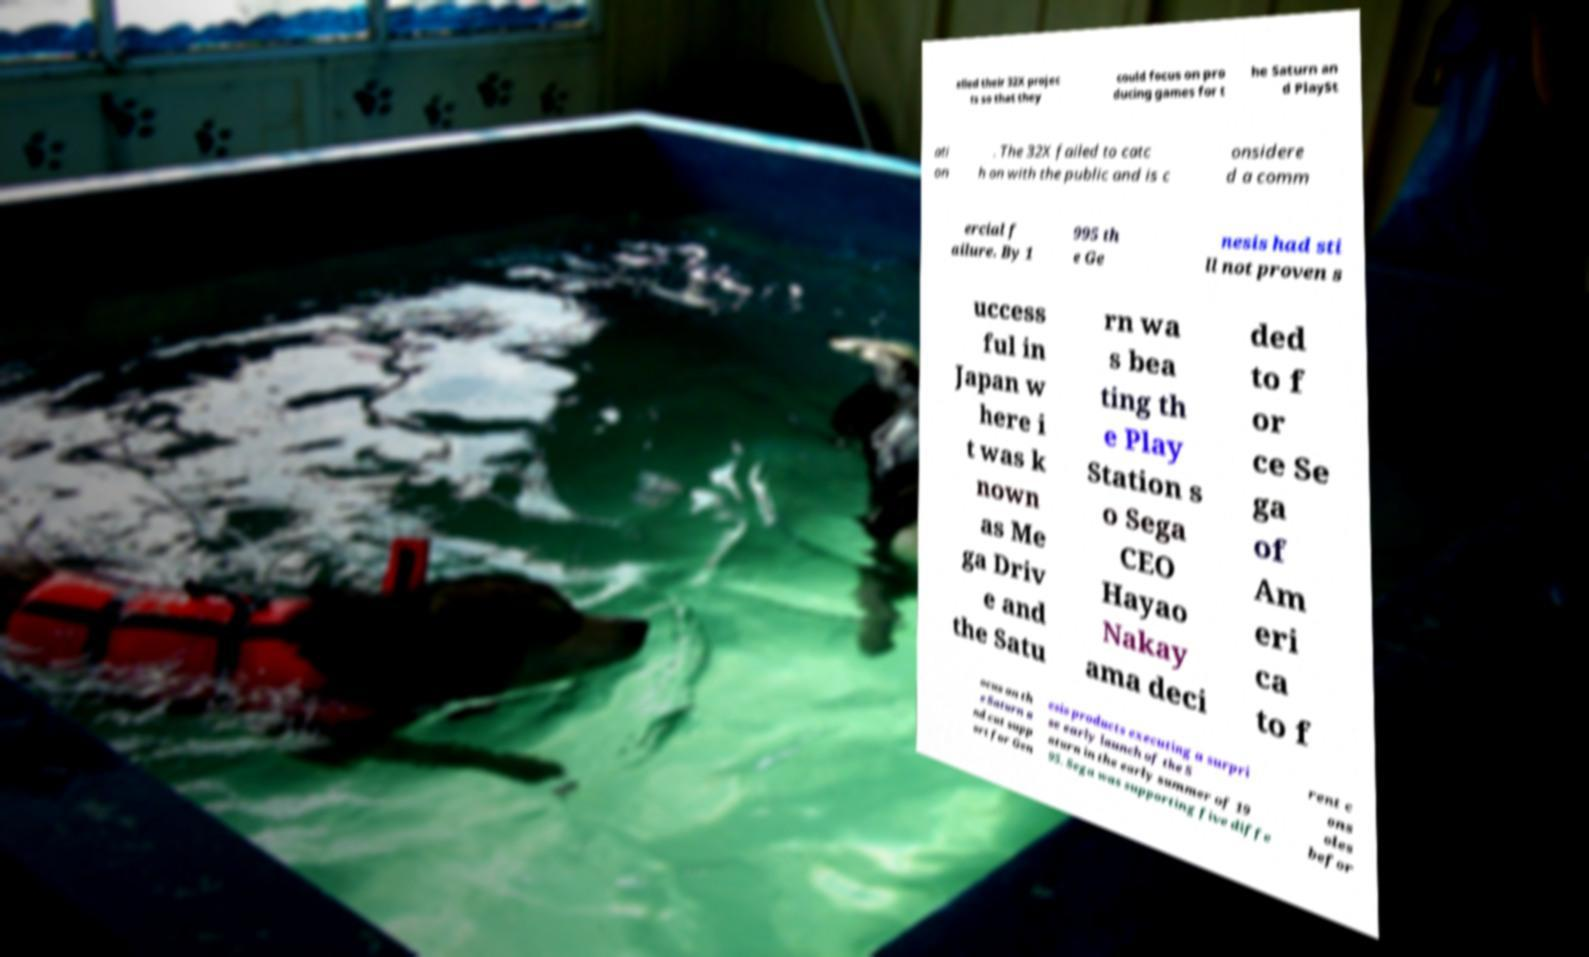Please read and relay the text visible in this image. What does it say? elled their 32X projec ts so that they could focus on pro ducing games for t he Saturn an d PlaySt ati on . The 32X failed to catc h on with the public and is c onsidere d a comm ercial f ailure. By 1 995 th e Ge nesis had sti ll not proven s uccess ful in Japan w here i t was k nown as Me ga Driv e and the Satu rn wa s bea ting th e Play Station s o Sega CEO Hayao Nakay ama deci ded to f or ce Se ga of Am eri ca to f ocus on th e Saturn a nd cut supp ort for Gen esis products executing a surpri se early launch of the S aturn in the early summer of 19 95. Sega was supporting five diffe rent c ons oles befor 